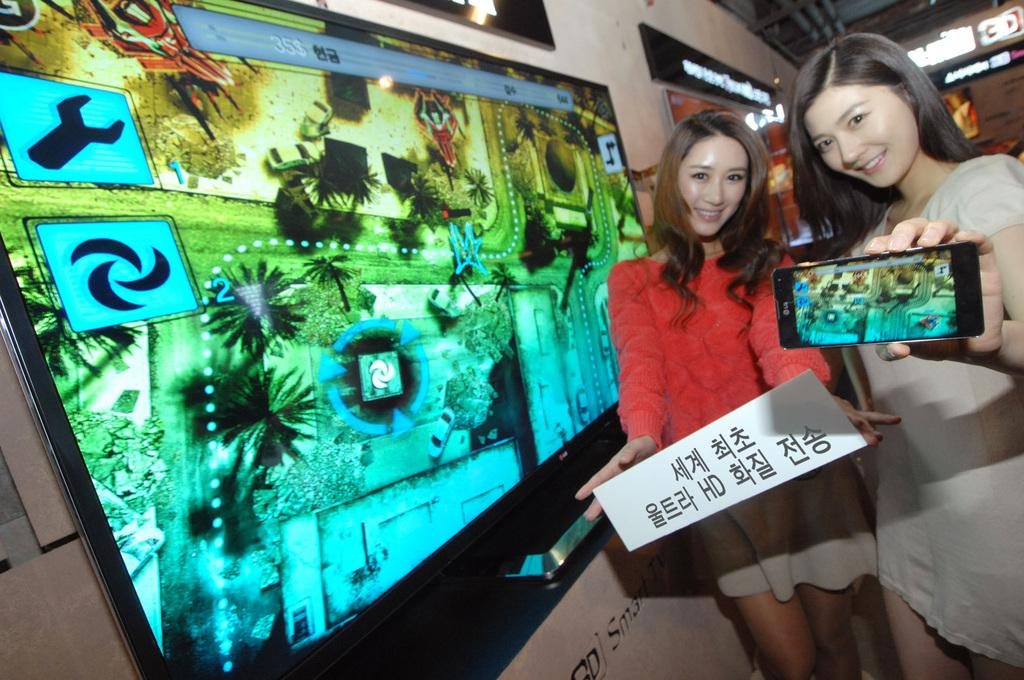How many people are in the image? There are two girls in the image. What are the girls holding in their hands? One of the girls is holding a phone, and the other girl is holding a board. What else can be seen beside the girls? There is a screen beside the girls. What type of statement is the judge making in the image? There is no judge present in the image, and therefore no statement can be attributed to a judge. 